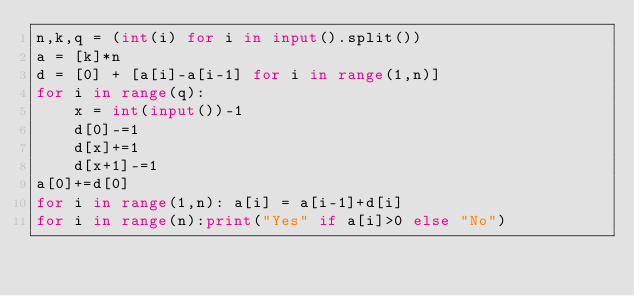<code> <loc_0><loc_0><loc_500><loc_500><_Python_>n,k,q = (int(i) for i in input().split())
a = [k]*n
d = [0] + [a[i]-a[i-1] for i in range(1,n)]
for i in range(q):
	x = int(input())-1
	d[0]-=1
	d[x]+=1
	d[x+1]-=1
a[0]+=d[0]
for i in range(1,n): a[i] = a[i-1]+d[i]
for i in range(n):print("Yes" if a[i]>0 else "No")
</code> 